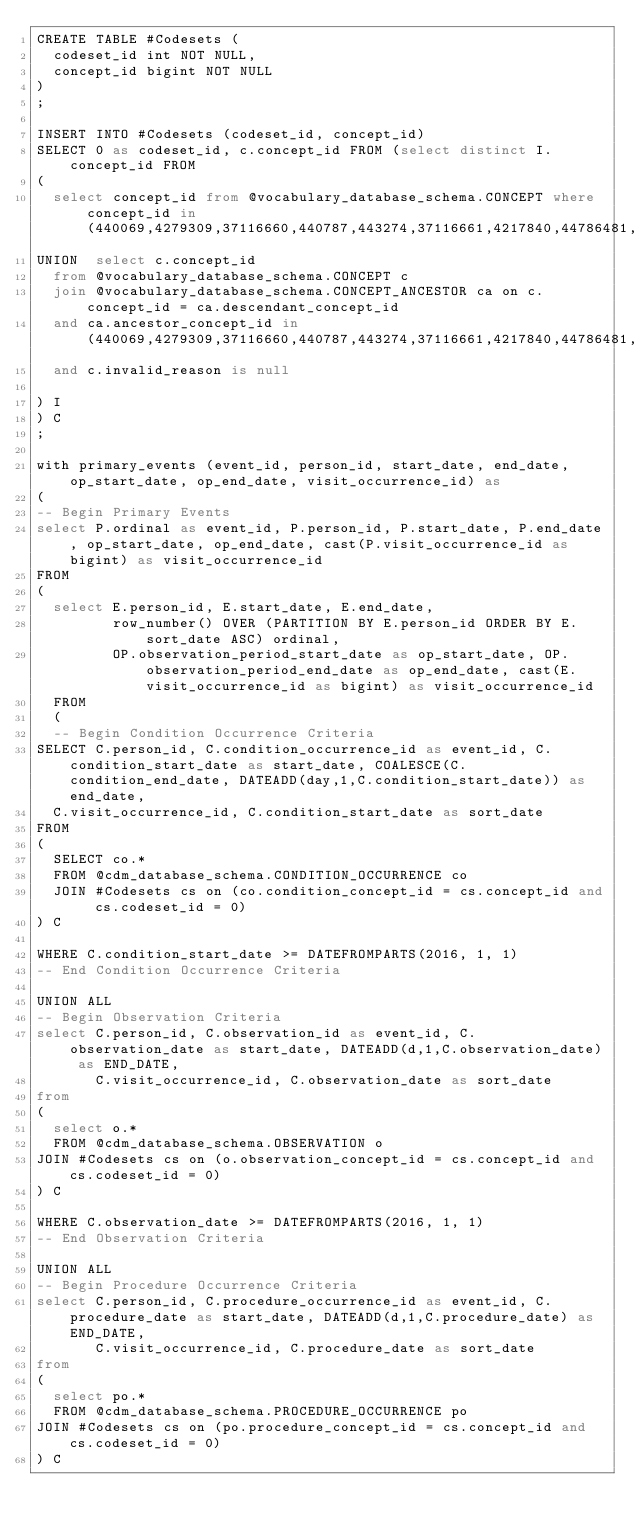Convert code to text. <code><loc_0><loc_0><loc_500><loc_500><_SQL_>CREATE TABLE #Codesets (
  codeset_id int NOT NULL,
  concept_id bigint NOT NULL
)
;

INSERT INTO #Codesets (codeset_id, concept_id)
SELECT 0 as codeset_id, c.concept_id FROM (select distinct I.concept_id FROM
( 
  select concept_id from @vocabulary_database_schema.CONCEPT where concept_id in (440069,4279309,37116660,440787,443274,37116661,4217840,44786481,434697,4302387,2796056,44790195,4149607,4219382,4269905,44787894,4004672,4151569,4319165)
UNION  select c.concept_id
  from @vocabulary_database_schema.CONCEPT c
  join @vocabulary_database_schema.CONCEPT_ANCESTOR ca on c.concept_id = ca.descendant_concept_id
  and ca.ancestor_concept_id in (440069,4279309,37116660,440787,443274,37116661,4217840,44786481,434697,4302387,2796056,44790195,4149607,4219382,4269905,44787894,4004672,4151569,4319165)
  and c.invalid_reason is null

) I
) C
;

with primary_events (event_id, person_id, start_date, end_date, op_start_date, op_end_date, visit_occurrence_id) as
(
-- Begin Primary Events
select P.ordinal as event_id, P.person_id, P.start_date, P.end_date, op_start_date, op_end_date, cast(P.visit_occurrence_id as bigint) as visit_occurrence_id
FROM
(
  select E.person_id, E.start_date, E.end_date,
         row_number() OVER (PARTITION BY E.person_id ORDER BY E.sort_date ASC) ordinal,
         OP.observation_period_start_date as op_start_date, OP.observation_period_end_date as op_end_date, cast(E.visit_occurrence_id as bigint) as visit_occurrence_id
  FROM 
  (
  -- Begin Condition Occurrence Criteria
SELECT C.person_id, C.condition_occurrence_id as event_id, C.condition_start_date as start_date, COALESCE(C.condition_end_date, DATEADD(day,1,C.condition_start_date)) as end_date,
  C.visit_occurrence_id, C.condition_start_date as sort_date
FROM 
(
  SELECT co.* 
  FROM @cdm_database_schema.CONDITION_OCCURRENCE co
  JOIN #Codesets cs on (co.condition_concept_id = cs.concept_id and cs.codeset_id = 0)
) C

WHERE C.condition_start_date >= DATEFROMPARTS(2016, 1, 1)
-- End Condition Occurrence Criteria

UNION ALL
-- Begin Observation Criteria
select C.person_id, C.observation_id as event_id, C.observation_date as start_date, DATEADD(d,1,C.observation_date) as END_DATE,
       C.visit_occurrence_id, C.observation_date as sort_date
from 
(
  select o.* 
  FROM @cdm_database_schema.OBSERVATION o
JOIN #Codesets cs on (o.observation_concept_id = cs.concept_id and cs.codeset_id = 0)
) C

WHERE C.observation_date >= DATEFROMPARTS(2016, 1, 1)
-- End Observation Criteria

UNION ALL
-- Begin Procedure Occurrence Criteria
select C.person_id, C.procedure_occurrence_id as event_id, C.procedure_date as start_date, DATEADD(d,1,C.procedure_date) as END_DATE,
       C.visit_occurrence_id, C.procedure_date as sort_date
from 
(
  select po.* 
  FROM @cdm_database_schema.PROCEDURE_OCCURRENCE po
JOIN #Codesets cs on (po.procedure_concept_id = cs.concept_id and cs.codeset_id = 0)
) C
</code> 